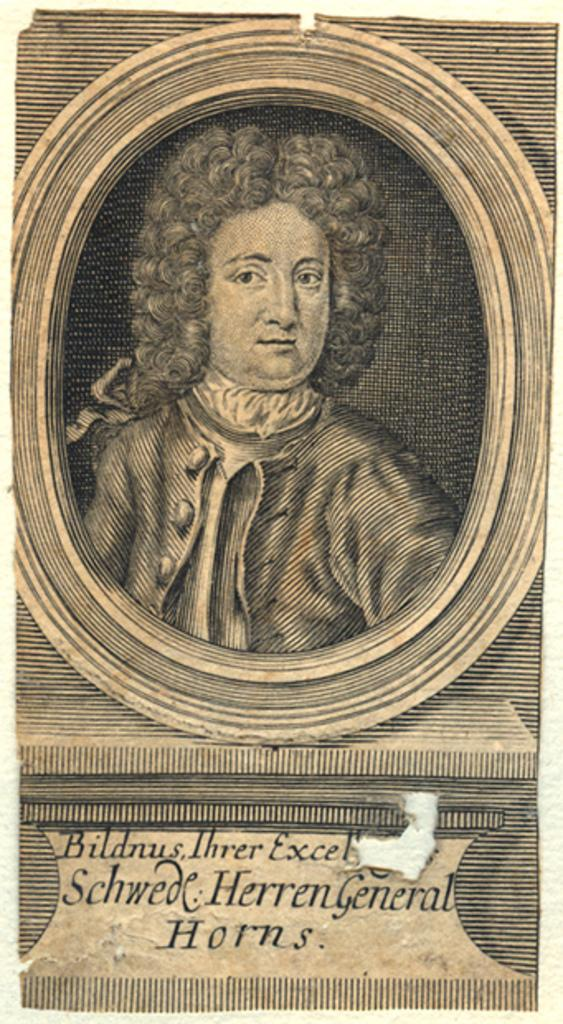<image>
Share a concise interpretation of the image provided. A portrait of a man in a wig with Bildnus Three Excel Schwede Herren General Horns in text under it. 